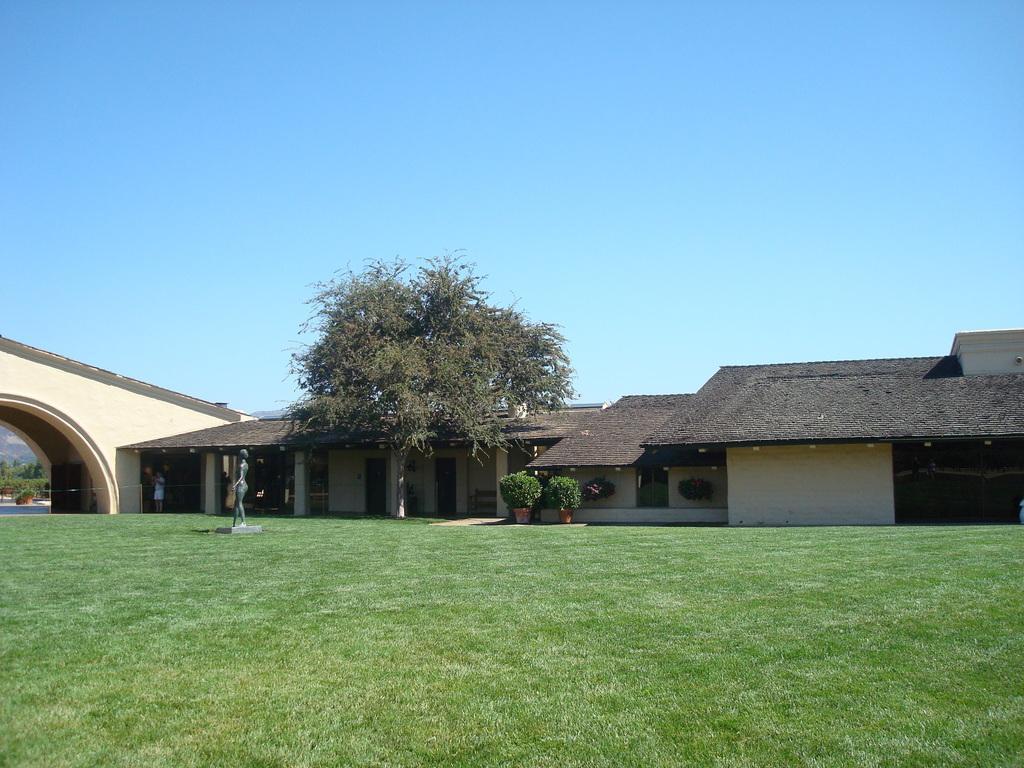Please provide a concise description of this image. In this image I can see there are houses and trees, at the bottom it is the grass, at the top it is the sky. 